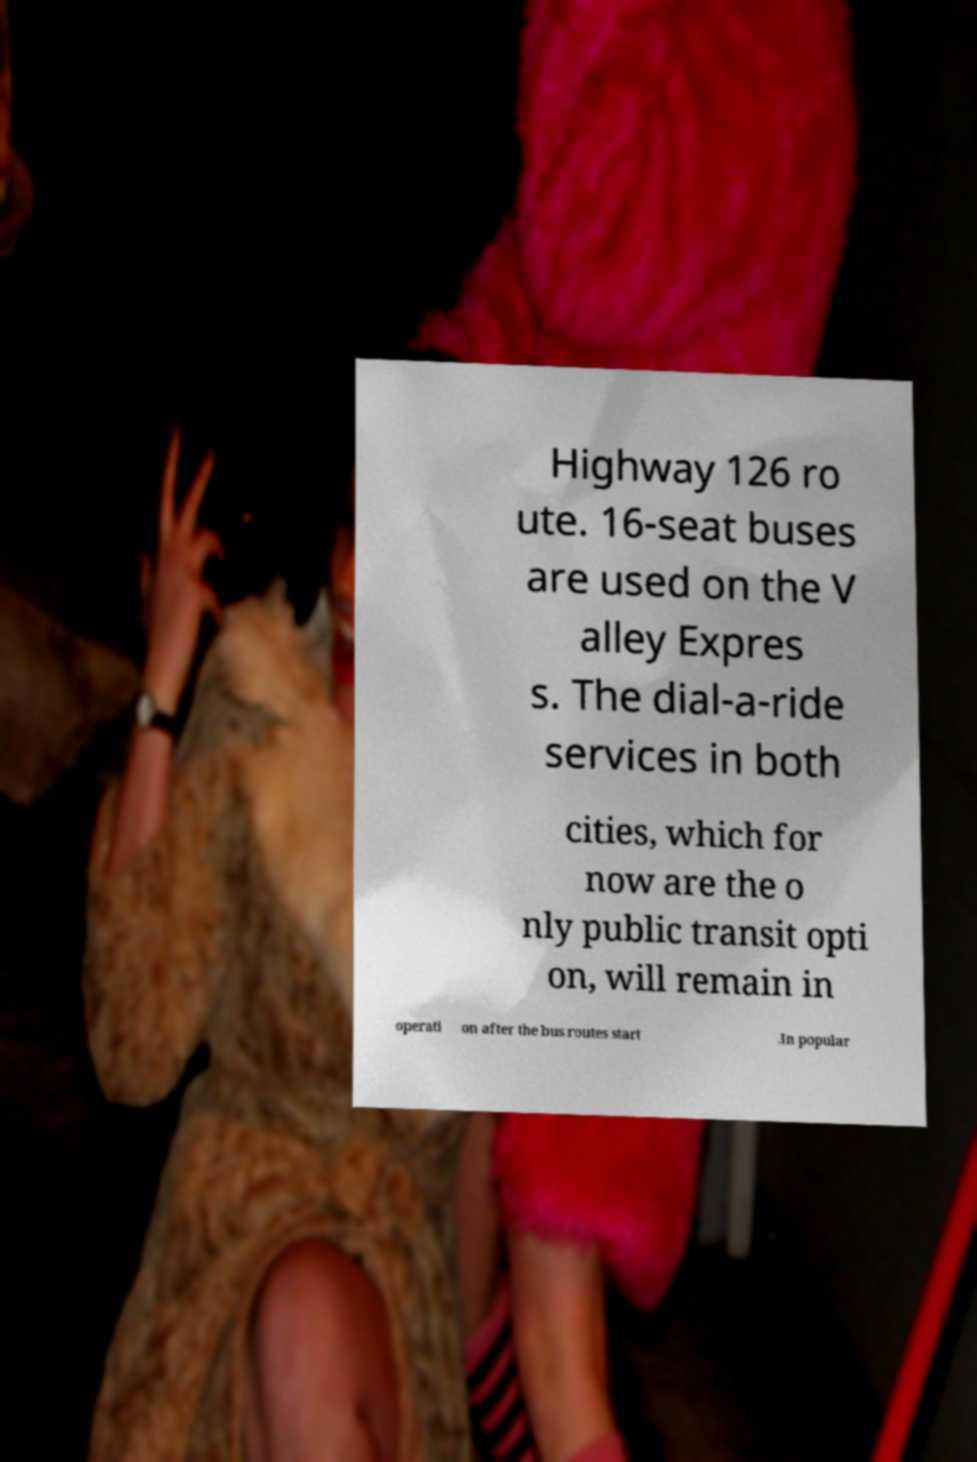Please identify and transcribe the text found in this image. Highway 126 ro ute. 16-seat buses are used on the V alley Expres s. The dial-a-ride services in both cities, which for now are the o nly public transit opti on, will remain in operati on after the bus routes start .In popular 